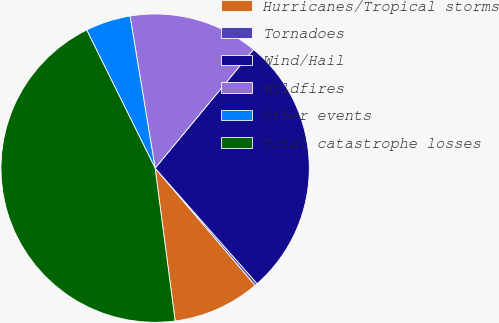Convert chart to OTSL. <chart><loc_0><loc_0><loc_500><loc_500><pie_chart><fcel>Hurricanes/Tropical storms<fcel>Tornadoes<fcel>Wind/Hail<fcel>Wildfires<fcel>Other events<fcel>Total catastrophe losses<nl><fcel>9.17%<fcel>0.27%<fcel>27.47%<fcel>13.62%<fcel>4.72%<fcel>44.76%<nl></chart> 